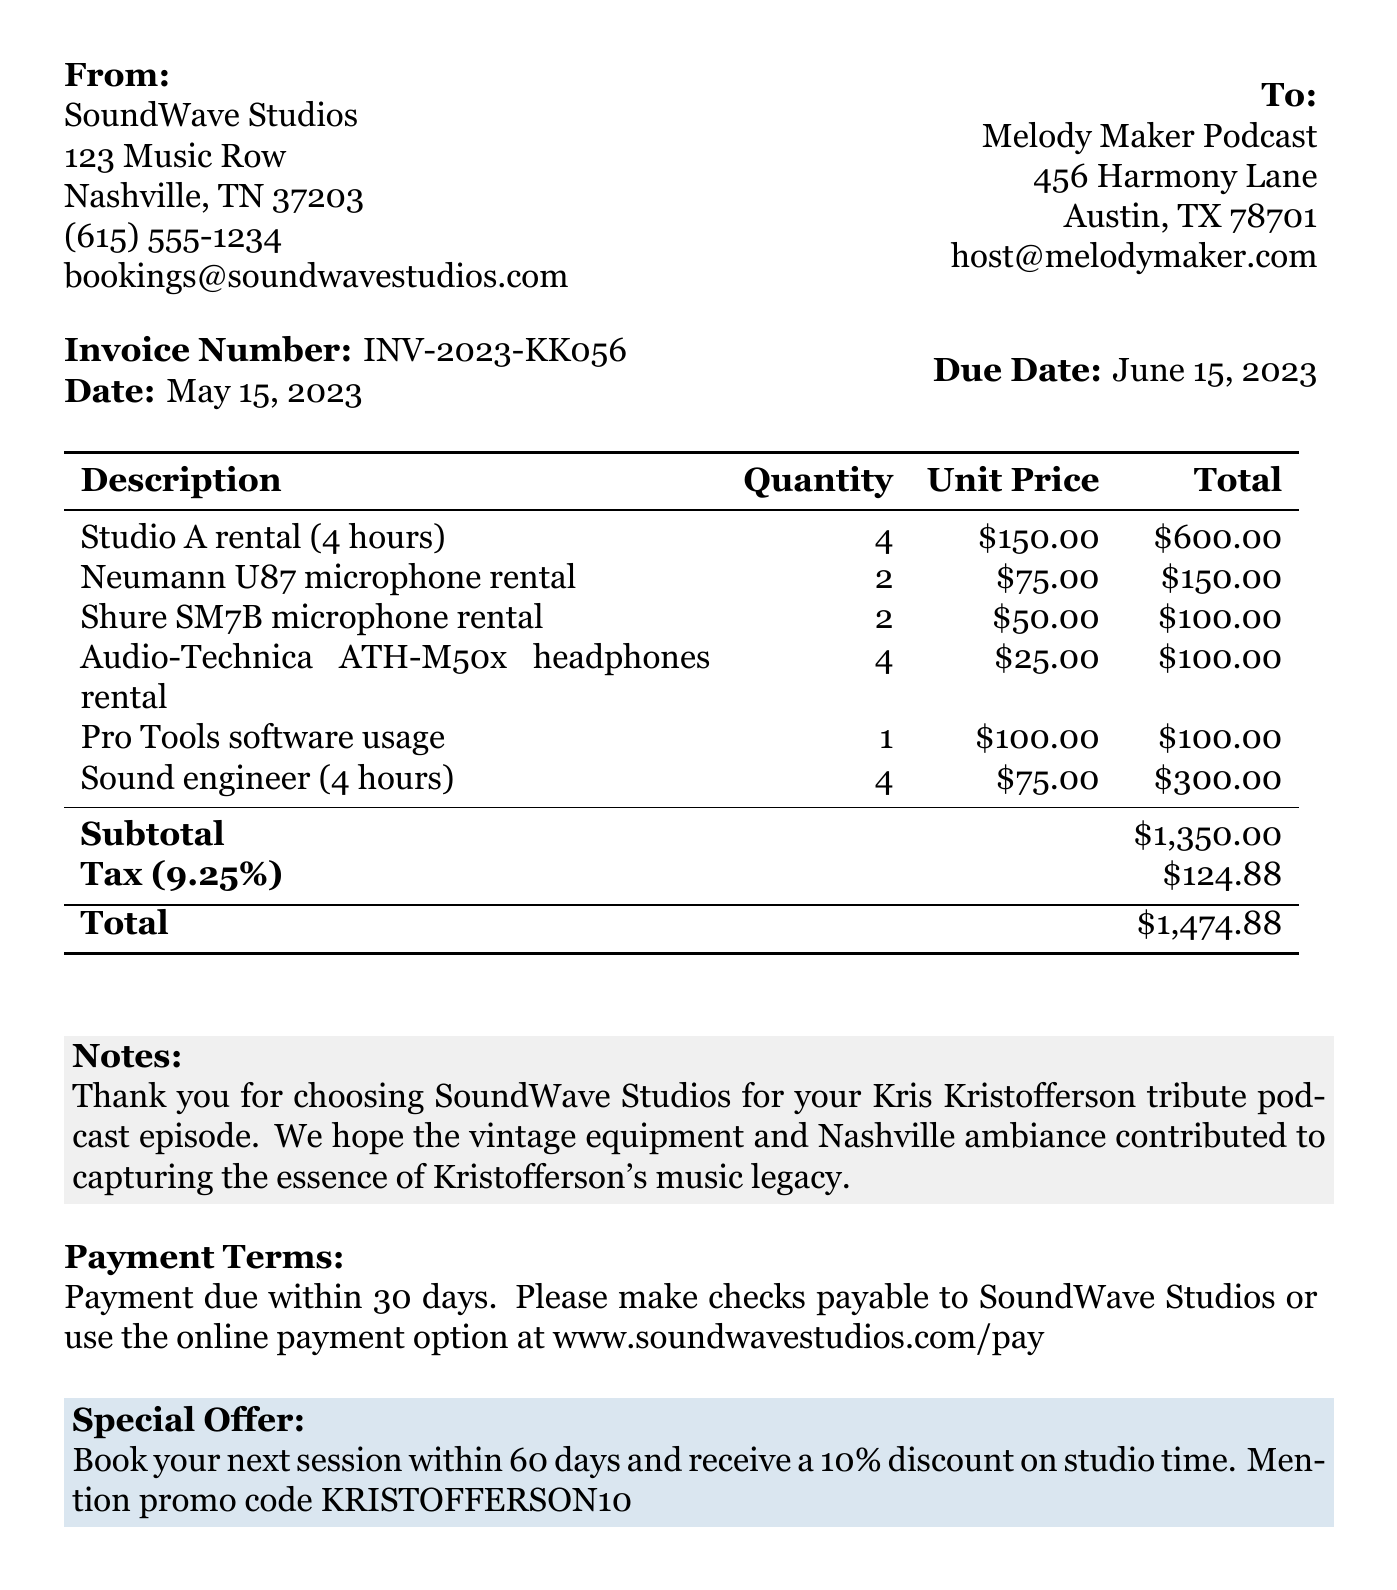what is the invoice number? The invoice number is a unique identifier for this document, which is specified in the document.
Answer: INV-2023-KK056 what is the due date? The due date indicates when the payment is expected to be made, as stated in the invoice.
Answer: June 15, 2023 who is the recipient of the invoice? The recipient is the entity to whom the invoice is issued, found under the "To:" section of the document.
Answer: Melody Maker Podcast what is the subtotal amount? The subtotal represents the total of all items before tax, as indicated in the document's itemized list.
Answer: $1,350.00 how many Neumann U87 microphones were rented? This question seeks the specific quantity of a certain item listed in the invoice.
Answer: 2 what is the tax rate applied to the invoice? The tax rate is the percentage of tax applied to the subtotal, specified in the document.
Answer: 9.25% what is the total amount due? The total amount due is the final payment required, including subtotal and tax, stated at the bottom of the invoice.
Answer: $1,474.88 what is the special offer mentioned? The special offer provides an incentive for future bookings, as detailed in the document.
Answer: 10% discount on studio time who is the sender of the invoice? The sender is the entity issuing the invoice, which is listed in the "From:" section of the document.
Answer: SoundWave Studios 